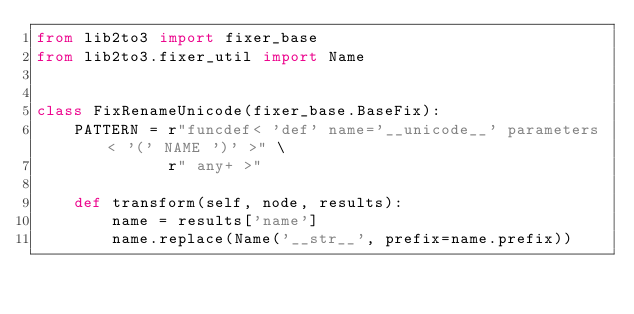Convert code to text. <code><loc_0><loc_0><loc_500><loc_500><_Python_>from lib2to3 import fixer_base
from lib2to3.fixer_util import Name


class FixRenameUnicode(fixer_base.BaseFix):
    PATTERN = r"funcdef< 'def' name='__unicode__' parameters< '(' NAME ')' >" \
              r" any+ >"

    def transform(self, node, results):
        name = results['name']
        name.replace(Name('__str__', prefix=name.prefix))
</code> 